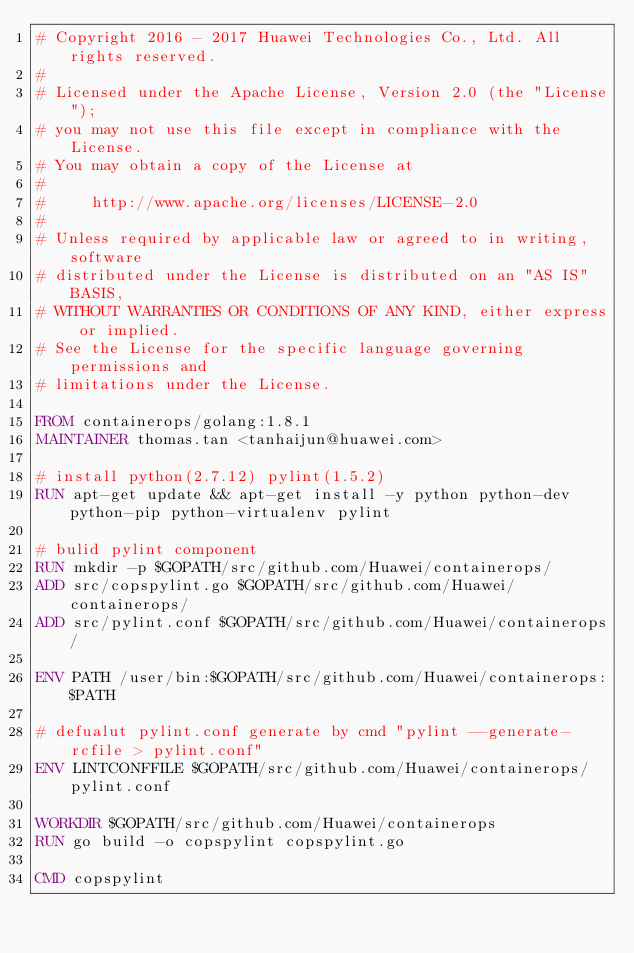<code> <loc_0><loc_0><loc_500><loc_500><_Dockerfile_># Copyright 2016 - 2017 Huawei Technologies Co., Ltd. All rights reserved.
#
# Licensed under the Apache License, Version 2.0 (the "License");
# you may not use this file except in compliance with the License.
# You may obtain a copy of the License at
#
#     http://www.apache.org/licenses/LICENSE-2.0
#
# Unless required by applicable law or agreed to in writing, software
# distributed under the License is distributed on an "AS IS" BASIS,
# WITHOUT WARRANTIES OR CONDITIONS OF ANY KIND, either express or implied.
# See the License for the specific language governing permissions and
# limitations under the License.

FROM containerops/golang:1.8.1
MAINTAINER thomas.tan <tanhaijun@huawei.com>

# install python(2.7.12) pylint(1.5.2)
RUN apt-get update && apt-get install -y python python-dev python-pip python-virtualenv pylint

# bulid pylint component
RUN mkdir -p $GOPATH/src/github.com/Huawei/containerops/
ADD src/copspylint.go $GOPATH/src/github.com/Huawei/containerops/
ADD src/pylint.conf $GOPATH/src/github.com/Huawei/containerops/

ENV PATH /user/bin:$GOPATH/src/github.com/Huawei/containerops:$PATH

# defualut pylint.conf generate by cmd "pylint --generate-rcfile > pylint.conf"
ENV LINTCONFFILE $GOPATH/src/github.com/Huawei/containerops/pylint.conf

WORKDIR $GOPATH/src/github.com/Huawei/containerops
RUN go build -o copspylint copspylint.go

CMD copspylint
</code> 